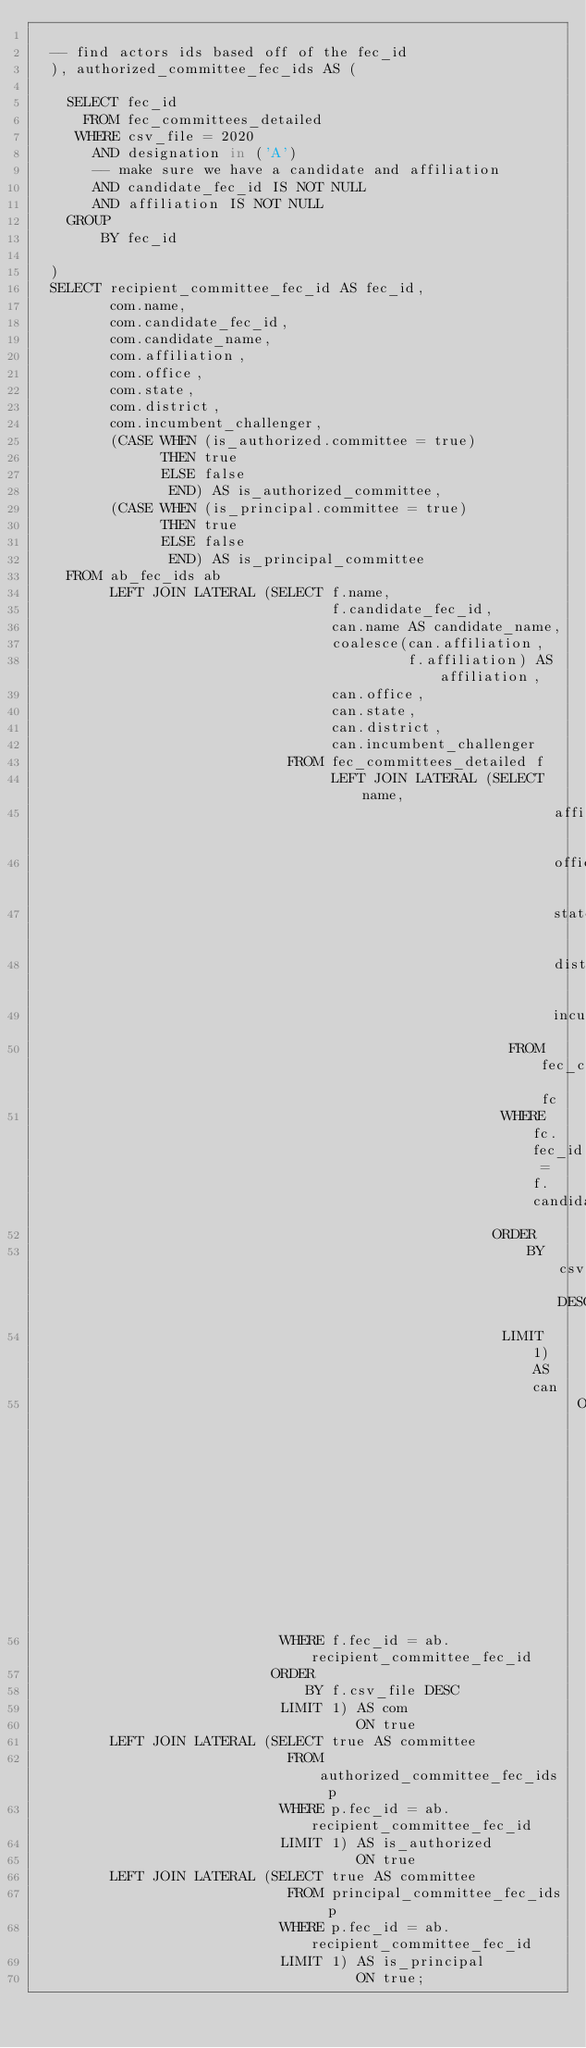Convert code to text. <code><loc_0><loc_0><loc_500><loc_500><_SQL_>
  -- find actors ids based off of the fec_id
  ), authorized_committee_fec_ids AS (

    SELECT fec_id
      FROM fec_committees_detailed
     WHERE csv_file = 2020
       AND designation in ('A')
       -- make sure we have a candidate and affiliation
       AND candidate_fec_id IS NOT NULL
       AND affiliation IS NOT NULL
    GROUP
        BY fec_id

  )
  SELECT recipient_committee_fec_id AS fec_id,
         com.name,
         com.candidate_fec_id,
         com.candidate_name,
         com.affiliation,
         com.office,
         com.state,
         com.district,
         com.incumbent_challenger,
         (CASE WHEN (is_authorized.committee = true)
               THEN true
               ELSE false
                END) AS is_authorized_committee,
         (CASE WHEN (is_principal.committee = true)
               THEN true
               ELSE false
                END) AS is_principal_committee
    FROM ab_fec_ids ab
         LEFT JOIN LATERAL (SELECT f.name,
                                   f.candidate_fec_id,
                                   can.name AS candidate_name,
                                   coalesce(can.affiliation,
                                            f.affiliation) AS affiliation,
                                   can.office,
                                   can.state,
                                   can.district,
                                   can.incumbent_challenger
                              FROM fec_committees_detailed f
                                   LEFT JOIN LATERAL (SELECT name,
                                                             affiliation,
                                                             office,
                                                             state,
                                                             district,
                                                             incumbent_challenger
                                                        FROM fec_candidates_detailed fc
                                                       WHERE fc.fec_id = f.candidate_fec_id
                                                      ORDER
                                                          BY csv_file DESC
                                                       LIMIT 1) AS can
                                                                ON (f.candidate_fec_id IS NOT NULL)
                             WHERE f.fec_id = ab.recipient_committee_fec_id
                            ORDER
                                BY f.csv_file DESC
                             LIMIT 1) AS com
                                      ON true
         LEFT JOIN LATERAL (SELECT true AS committee
                              FROM authorized_committee_fec_ids p
                             WHERE p.fec_id = ab.recipient_committee_fec_id
                             LIMIT 1) AS is_authorized
                                      ON true
         LEFT JOIN LATERAL (SELECT true AS committee
                              FROM principal_committee_fec_ids p
                             WHERE p.fec_id = ab.recipient_committee_fec_id
                             LIMIT 1) AS is_principal
                                      ON true;




</code> 